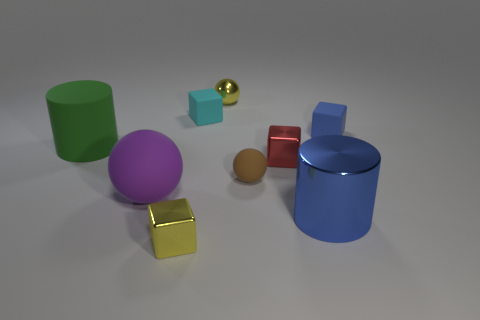Subtract all rubber balls. How many balls are left? 1 Subtract all cylinders. How many objects are left? 7 Subtract 4 cubes. How many cubes are left? 0 Add 1 rubber blocks. How many rubber blocks exist? 3 Subtract all green cylinders. How many cylinders are left? 1 Subtract 0 purple cylinders. How many objects are left? 9 Subtract all gray balls. Subtract all green cylinders. How many balls are left? 3 Subtract all blue cylinders. How many green blocks are left? 0 Subtract all small yellow spheres. Subtract all small brown objects. How many objects are left? 7 Add 9 yellow cubes. How many yellow cubes are left? 10 